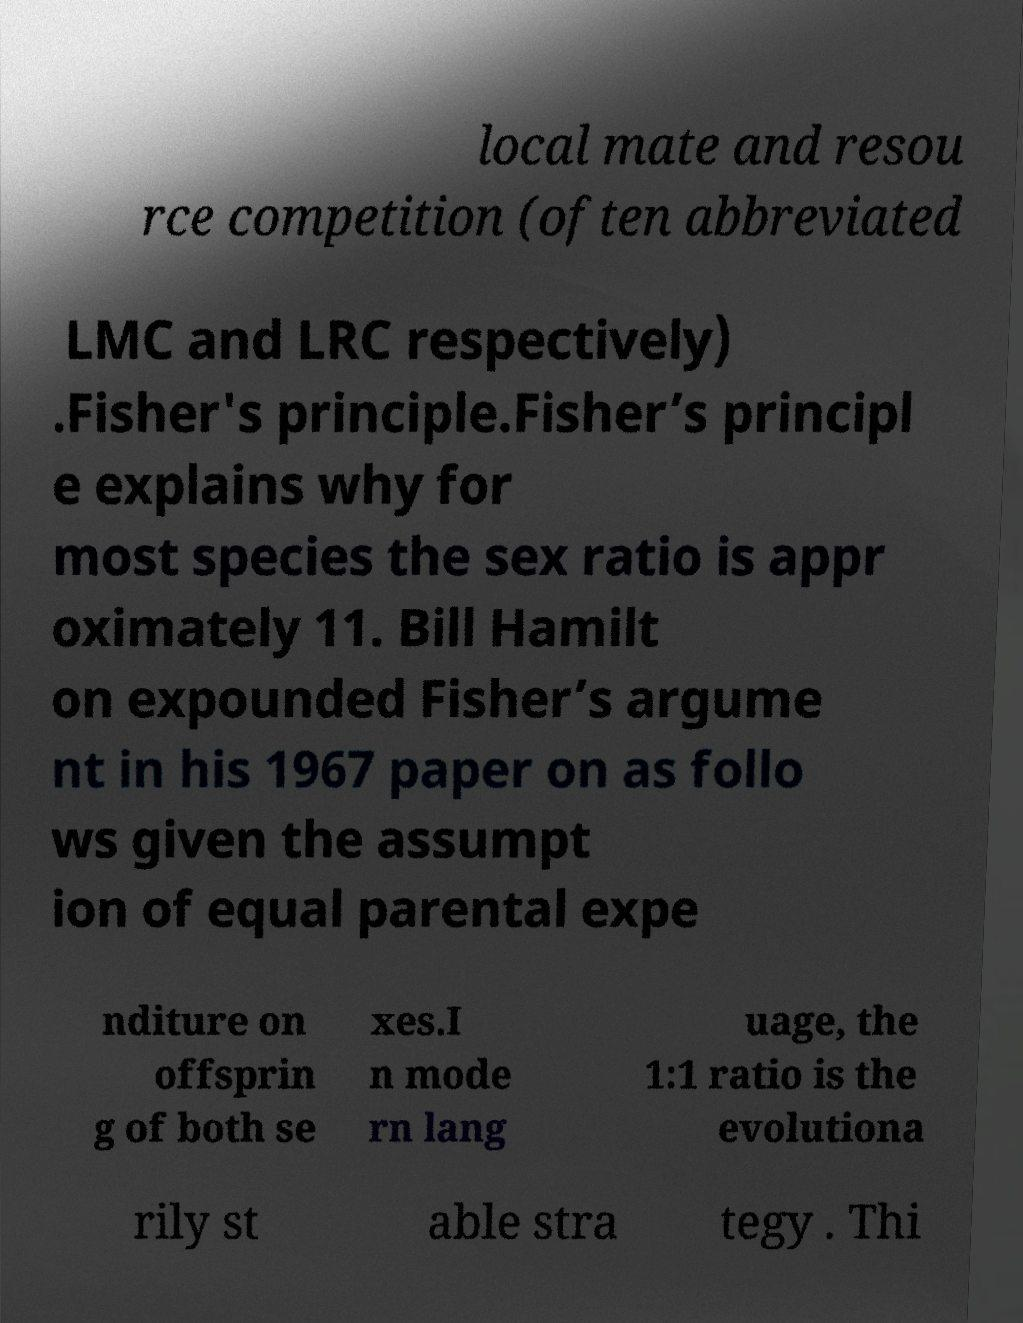Please read and relay the text visible in this image. What does it say? local mate and resou rce competition (often abbreviated LMC and LRC respectively) .Fisher's principle.Fisher’s principl e explains why for most species the sex ratio is appr oximately 11. Bill Hamilt on expounded Fisher’s argume nt in his 1967 paper on as follo ws given the assumpt ion of equal parental expe nditure on offsprin g of both se xes.I n mode rn lang uage, the 1:1 ratio is the evolutiona rily st able stra tegy . Thi 